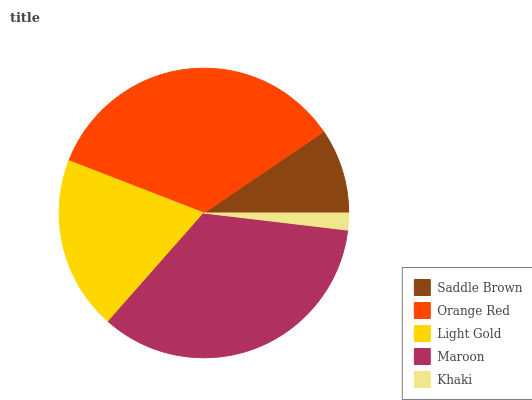Is Khaki the minimum?
Answer yes or no. Yes. Is Orange Red the maximum?
Answer yes or no. Yes. Is Light Gold the minimum?
Answer yes or no. No. Is Light Gold the maximum?
Answer yes or no. No. Is Orange Red greater than Light Gold?
Answer yes or no. Yes. Is Light Gold less than Orange Red?
Answer yes or no. Yes. Is Light Gold greater than Orange Red?
Answer yes or no. No. Is Orange Red less than Light Gold?
Answer yes or no. No. Is Light Gold the high median?
Answer yes or no. Yes. Is Light Gold the low median?
Answer yes or no. Yes. Is Maroon the high median?
Answer yes or no. No. Is Saddle Brown the low median?
Answer yes or no. No. 